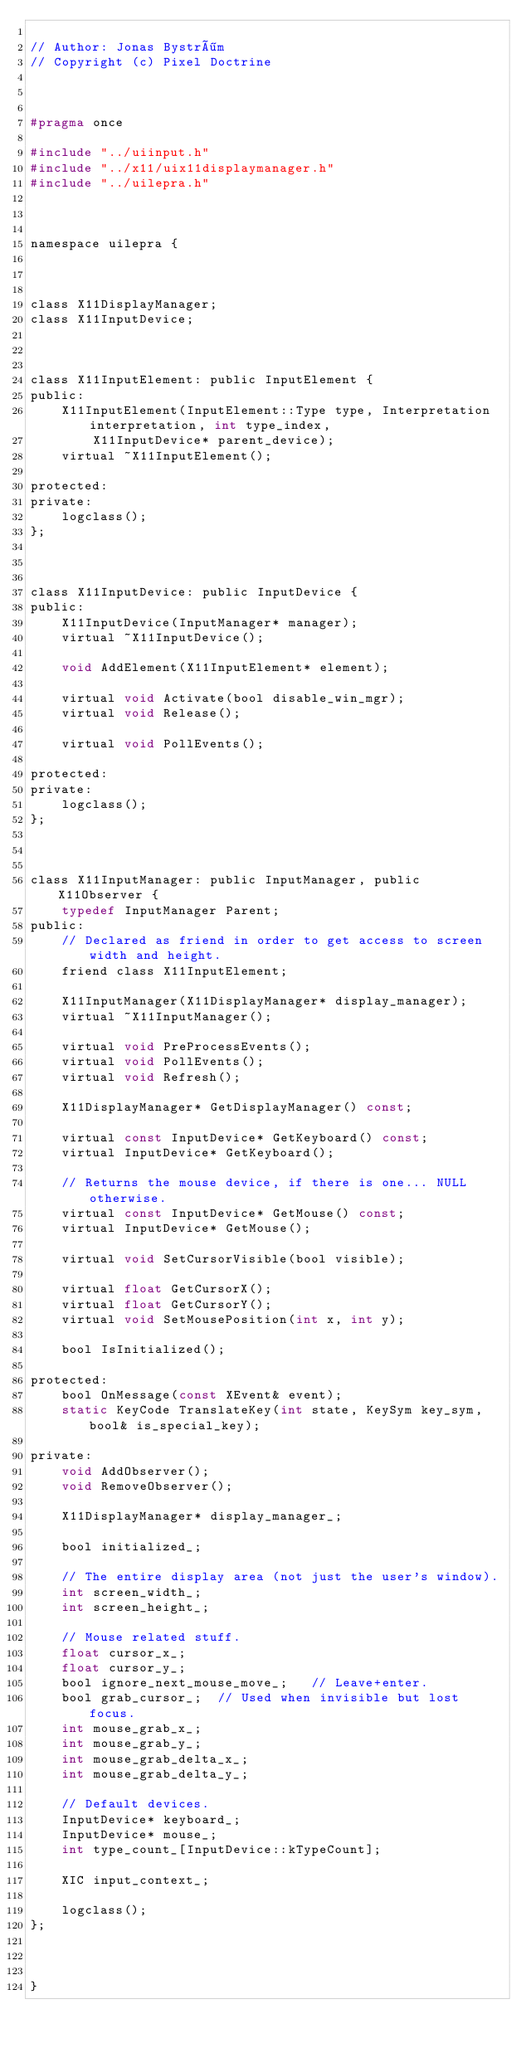Convert code to text. <code><loc_0><loc_0><loc_500><loc_500><_C_>
// Author: Jonas Byström
// Copyright (c) Pixel Doctrine



#pragma once

#include "../uiinput.h"
#include "../x11/uix11displaymanager.h"
#include "../uilepra.h"



namespace uilepra {



class X11DisplayManager;
class X11InputDevice;



class X11InputElement: public InputElement {
public:
	X11InputElement(InputElement::Type type, Interpretation interpretation, int type_index,
		X11InputDevice* parent_device);
	virtual ~X11InputElement();

protected:
private:
	logclass();
};



class X11InputDevice: public InputDevice {
public:
	X11InputDevice(InputManager* manager);
	virtual ~X11InputDevice();

	void AddElement(X11InputElement* element);

	virtual void Activate(bool disable_win_mgr);
	virtual void Release();

	virtual void PollEvents();

protected:
private:
	logclass();
};



class X11InputManager: public InputManager, public X11Observer {
	typedef InputManager Parent;
public:
	// Declared as friend in order to get access to screen width and height.
	friend class X11InputElement;

	X11InputManager(X11DisplayManager* display_manager);
	virtual ~X11InputManager();

	virtual void PreProcessEvents();
	virtual void PollEvents();
	virtual void Refresh();

	X11DisplayManager* GetDisplayManager() const;

	virtual const InputDevice* GetKeyboard() const;
	virtual InputDevice* GetKeyboard();

	// Returns the mouse device, if there is one... NULL otherwise.
	virtual const InputDevice* GetMouse() const;
	virtual InputDevice* GetMouse();

	virtual void SetCursorVisible(bool visible);

	virtual float GetCursorX();
	virtual float GetCursorY();
	virtual void SetMousePosition(int x, int y);

	bool IsInitialized();

protected:
	bool OnMessage(const XEvent& event);
	static KeyCode TranslateKey(int state, KeySym key_sym, bool& is_special_key);

private:
	void AddObserver();
	void RemoveObserver();

	X11DisplayManager* display_manager_;

	bool initialized_;

	// The entire display area (not just the user's window).
	int screen_width_;
	int screen_height_;

	// Mouse related stuff.
	float cursor_x_;
	float cursor_y_;
	bool ignore_next_mouse_move_;	// Leave+enter.
	bool grab_cursor_;	// Used when invisible but lost focus.
	int mouse_grab_x_;
	int mouse_grab_y_;
	int mouse_grab_delta_x_;
	int mouse_grab_delta_y_;

	// Default devices.
	InputDevice* keyboard_;
	InputDevice* mouse_;
	int type_count_[InputDevice::kTypeCount];

	XIC input_context_;

	logclass();
};



}
</code> 